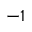<formula> <loc_0><loc_0><loc_500><loc_500>^ { - 1 }</formula> 